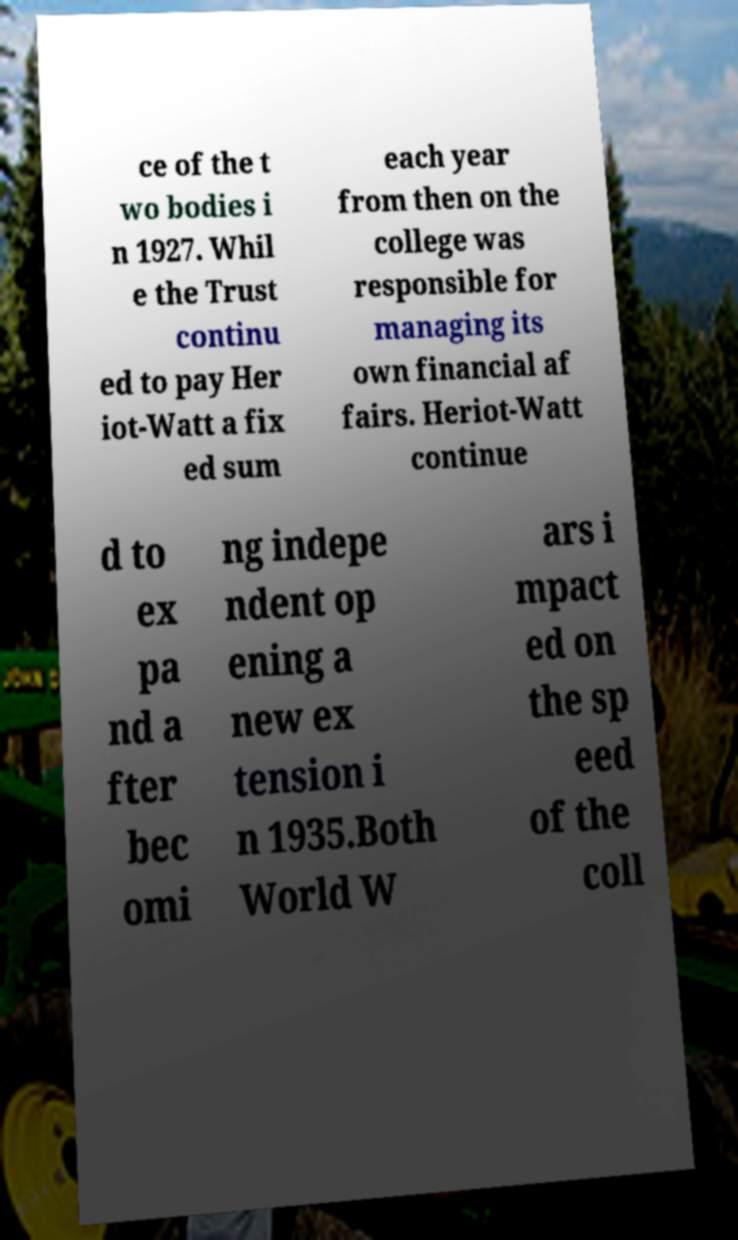What messages or text are displayed in this image? I need them in a readable, typed format. ce of the t wo bodies i n 1927. Whil e the Trust continu ed to pay Her iot-Watt a fix ed sum each year from then on the college was responsible for managing its own financial af fairs. Heriot-Watt continue d to ex pa nd a fter bec omi ng indepe ndent op ening a new ex tension i n 1935.Both World W ars i mpact ed on the sp eed of the coll 